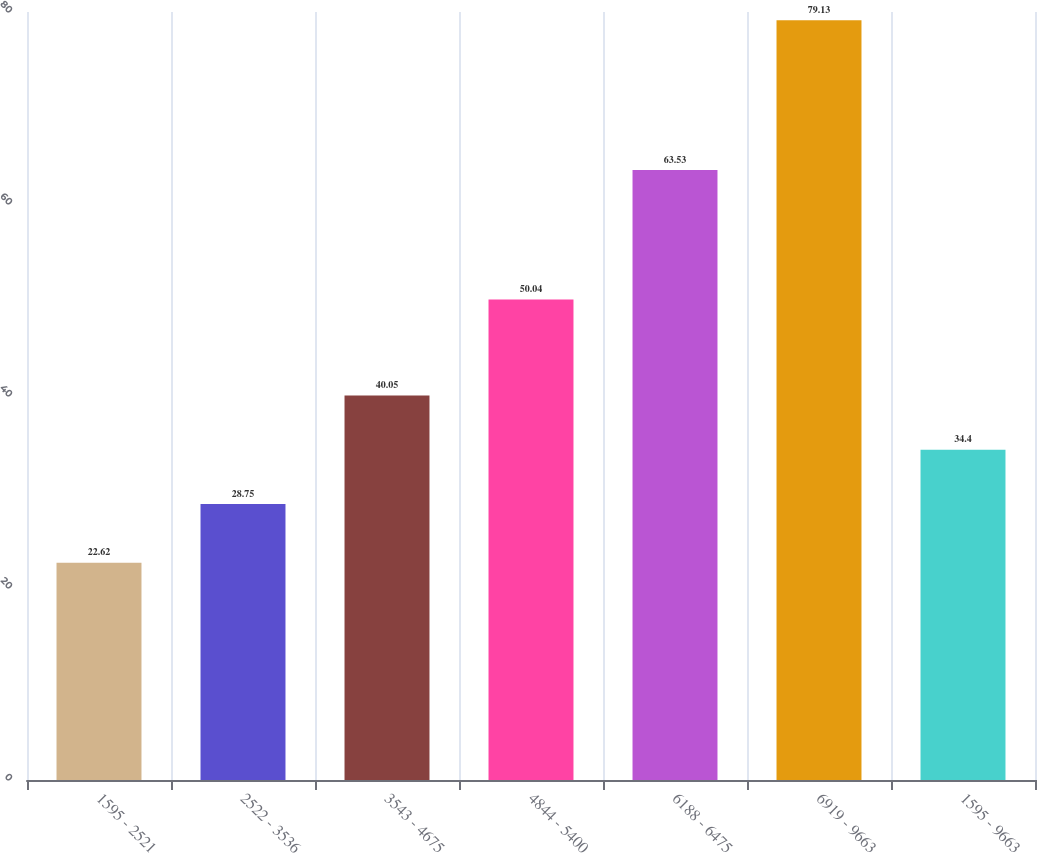<chart> <loc_0><loc_0><loc_500><loc_500><bar_chart><fcel>1595 - 2521<fcel>2522 - 3536<fcel>3543 - 4675<fcel>4844 - 5400<fcel>6188 - 6475<fcel>6919 - 9663<fcel>1595 - 9663<nl><fcel>22.62<fcel>28.75<fcel>40.05<fcel>50.04<fcel>63.53<fcel>79.13<fcel>34.4<nl></chart> 